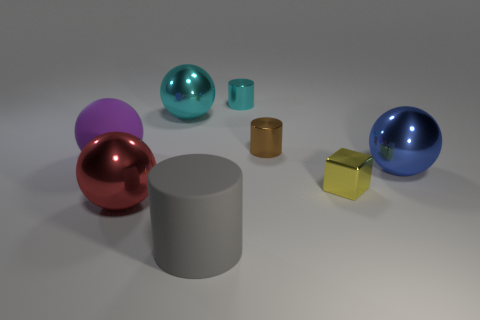Subtract all green spheres. Subtract all red blocks. How many spheres are left? 4 Add 1 yellow cylinders. How many objects exist? 9 Subtract all cylinders. How many objects are left? 5 Add 3 tiny gray metallic blocks. How many tiny gray metallic blocks exist? 3 Subtract 1 purple spheres. How many objects are left? 7 Subtract all blue metal spheres. Subtract all large cyan metal spheres. How many objects are left? 6 Add 4 big cyan shiny objects. How many big cyan shiny objects are left? 5 